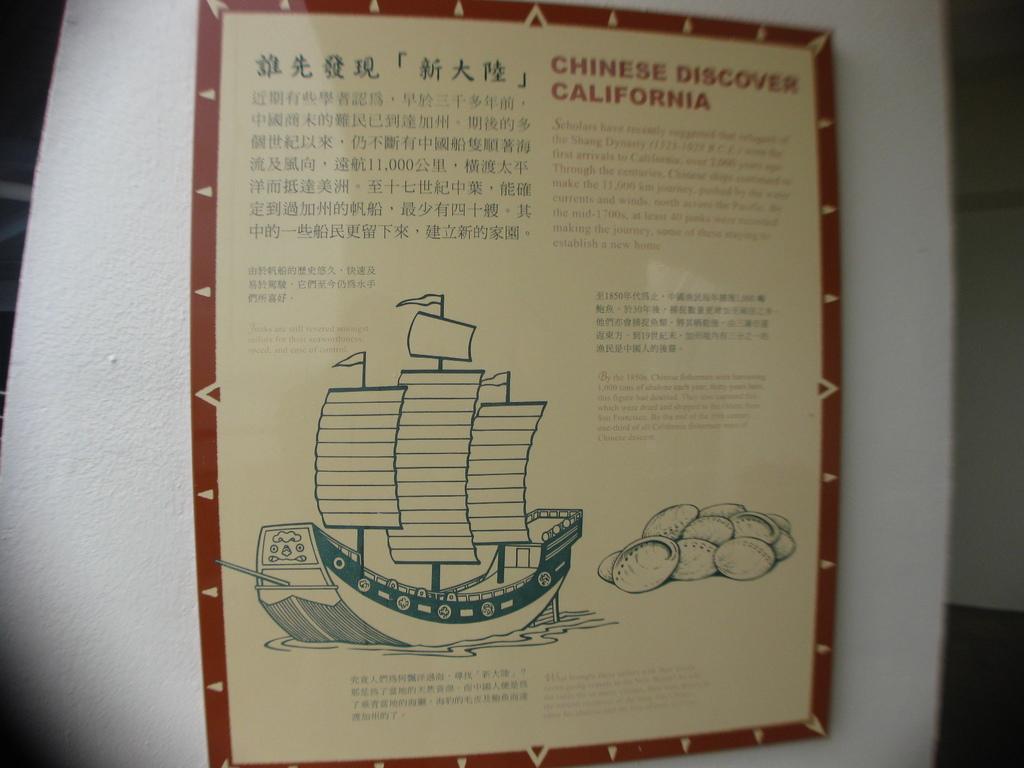What did the chinese discover?
Offer a very short reply. California. 